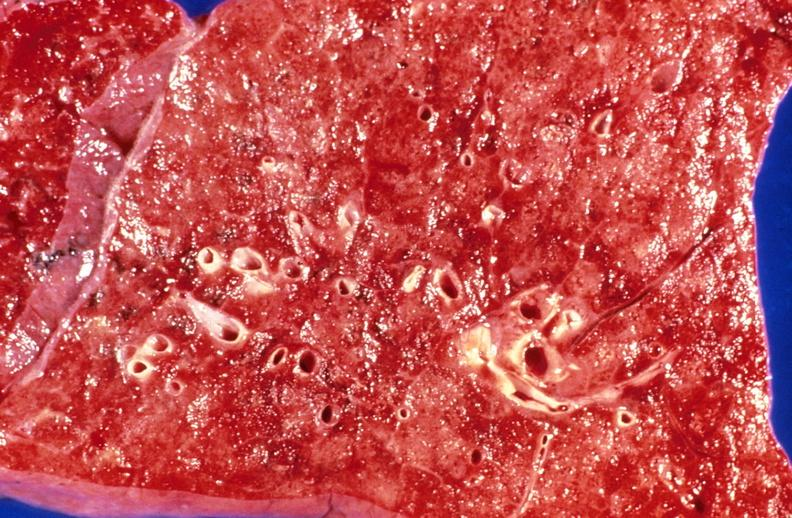what does this image show?
Answer the question using a single word or phrase. Aspiration pneumonia 